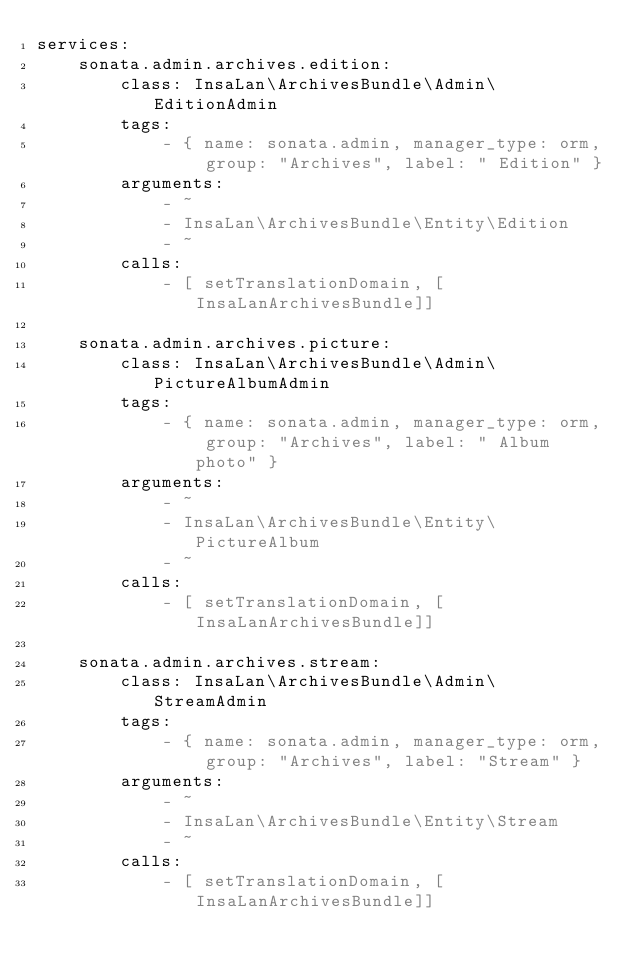Convert code to text. <code><loc_0><loc_0><loc_500><loc_500><_YAML_>services:
    sonata.admin.archives.edition:
        class: InsaLan\ArchivesBundle\Admin\EditionAdmin
        tags:
            - { name: sonata.admin, manager_type: orm, group: "Archives", label: " Edition" }
        arguments:
            - ~
            - InsaLan\ArchivesBundle\Entity\Edition
            - ~
        calls:
            - [ setTranslationDomain, [InsaLanArchivesBundle]]

    sonata.admin.archives.picture:
        class: InsaLan\ArchivesBundle\Admin\PictureAlbumAdmin
        tags:
            - { name: sonata.admin, manager_type: orm, group: "Archives", label: " Album photo" }
        arguments:
            - ~
            - InsaLan\ArchivesBundle\Entity\PictureAlbum
            - ~
        calls:
            - [ setTranslationDomain, [InsaLanArchivesBundle]]

    sonata.admin.archives.stream:
        class: InsaLan\ArchivesBundle\Admin\StreamAdmin
        tags:
            - { name: sonata.admin, manager_type: orm, group: "Archives", label: "Stream" }
        arguments:
            - ~
            - InsaLan\ArchivesBundle\Entity\Stream
            - ~
        calls:
            - [ setTranslationDomain, [InsaLanArchivesBundle]]
</code> 